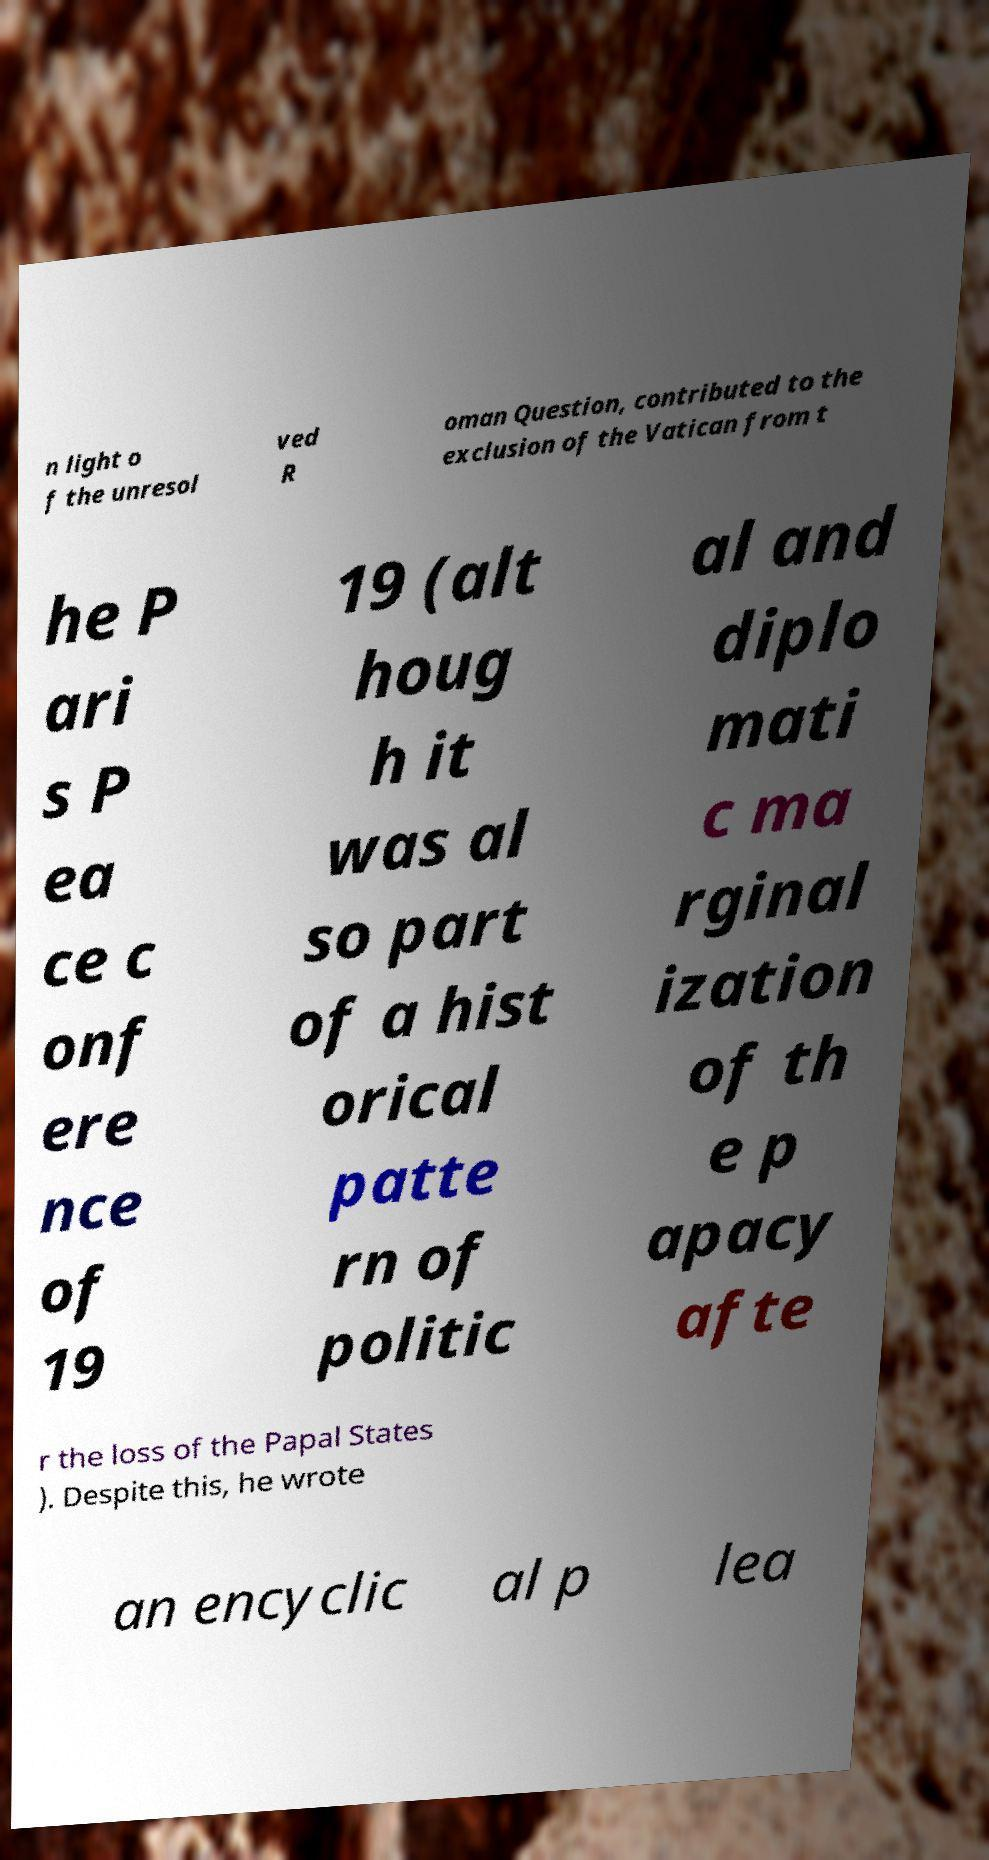For documentation purposes, I need the text within this image transcribed. Could you provide that? n light o f the unresol ved R oman Question, contributed to the exclusion of the Vatican from t he P ari s P ea ce c onf ere nce of 19 19 (alt houg h it was al so part of a hist orical patte rn of politic al and diplo mati c ma rginal ization of th e p apacy afte r the loss of the Papal States ). Despite this, he wrote an encyclic al p lea 